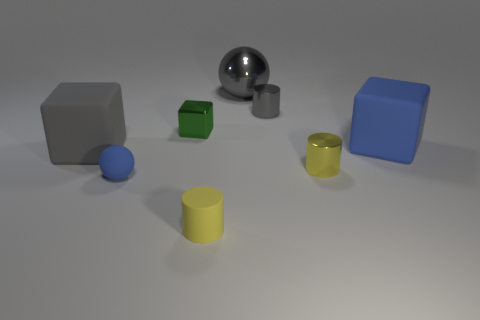Add 1 tiny cyan metallic balls. How many objects exist? 9 Subtract all spheres. How many objects are left? 6 Add 4 tiny blue matte spheres. How many tiny blue matte spheres exist? 5 Subtract 1 yellow cylinders. How many objects are left? 7 Subtract all small blue shiny objects. Subtract all green shiny blocks. How many objects are left? 7 Add 3 matte blocks. How many matte blocks are left? 5 